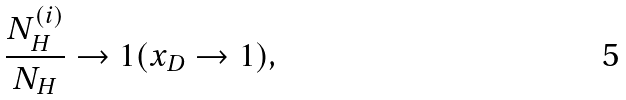Convert formula to latex. <formula><loc_0><loc_0><loc_500><loc_500>\frac { N _ { H } ^ { ( i ) } } { N _ { H } } \rightarrow 1 ( x _ { D } \rightarrow 1 ) ,</formula> 